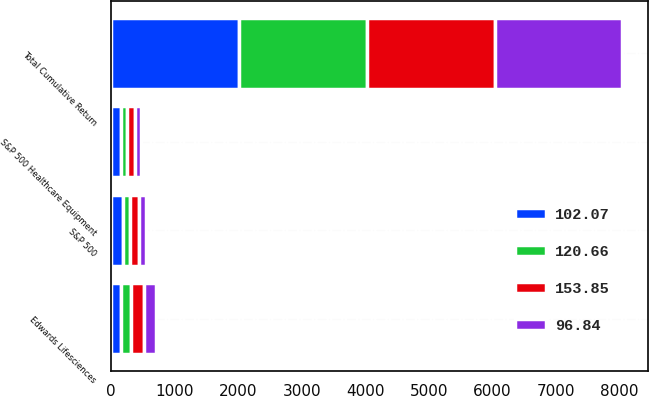Convert chart to OTSL. <chart><loc_0><loc_0><loc_500><loc_500><stacked_bar_chart><ecel><fcel>Total Cumulative Return<fcel>Edwards Lifesciences<fcel>S&P 500<fcel>S&P 500 Healthcare Equipment<nl><fcel>96.84<fcel>2010<fcel>186.16<fcel>115.06<fcel>96.84<nl><fcel>120.66<fcel>2011<fcel>162.81<fcel>117.49<fcel>102.07<nl><fcel>153.85<fcel>2012<fcel>207.65<fcel>136.3<fcel>120.66<nl><fcel>102.07<fcel>2013<fcel>151.43<fcel>180.44<fcel>153.85<nl></chart> 